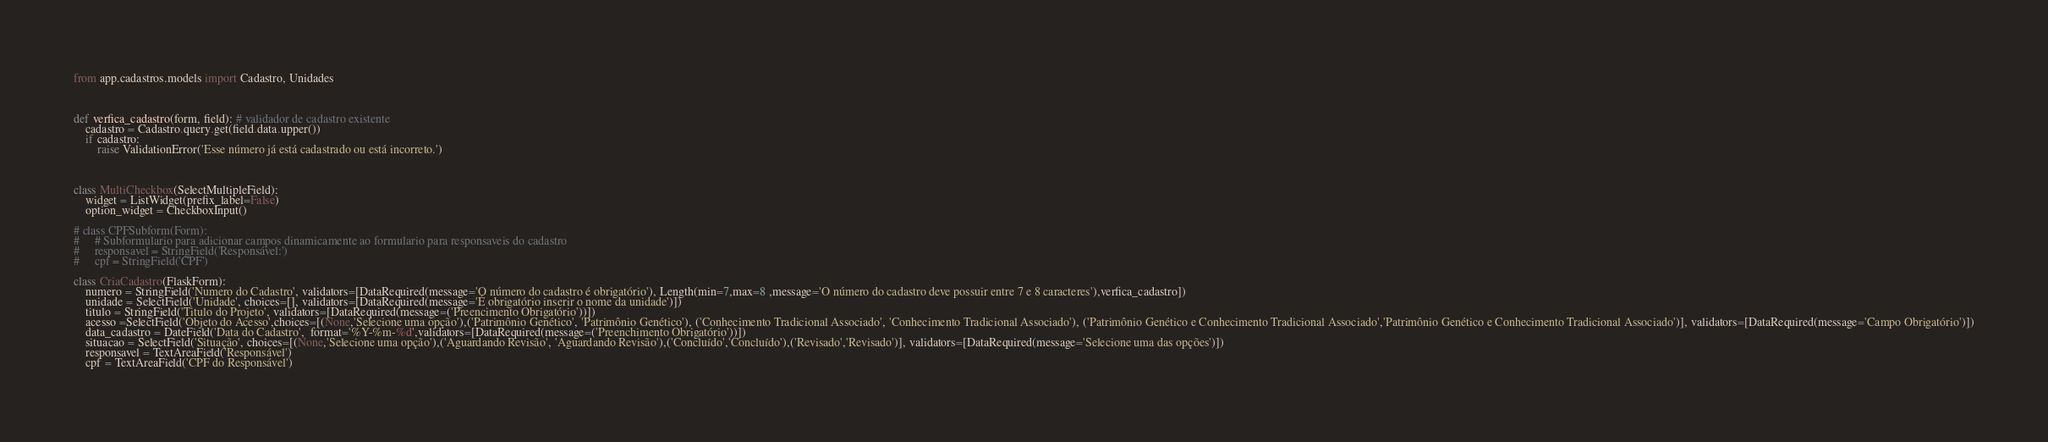Convert code to text. <code><loc_0><loc_0><loc_500><loc_500><_Python_>from app.cadastros.models import Cadastro, Unidades



def verfica_cadastro(form, field): # validador de cadastro existente
    cadastro = Cadastro.query.get(field.data.upper())
    if cadastro:
        raise ValidationError('Esse número já está cadastrado ou está incorreto.')



class MultiCheckbox(SelectMultipleField):
    widget = ListWidget(prefix_label=False)
    option_widget = CheckboxInput()

# class CPFSubform(Form):
#     # Subformulario para adicionar campos dinamicamente ao formulario para responsaveis do cadastro
#     responsavel = StringField('Responsável:')
#     cpf = StringField('CPF')

class CriaCadastro(FlaskForm):
    numero = StringField('Numero do Cadastro', validators=[DataRequired(message='O número do cadastro é obrigatório'), Length(min=7,max=8 ,message='O número do cadastro deve possuir entre 7 e 8 caracteres'),verfica_cadastro])
    unidade = SelectField('Unidade', choices=[], validators=[DataRequired(message='É obrigatório inserir o nome da unidade')])
    titulo = StringField('Titulo do Projeto', validators=[DataRequired(message=('Preencimento Obrigatório'))])
    acesso =SelectField('Objeto do Acesso',choices=[(None,'Selecione uma opção'),('Patrimônio Genético', 'Patrimônio Genético'), ('Conhecimento Tradicional Associado', 'Conhecimento Tradicional Associado'), ('Patrimônio Genético e Conhecimento Tradicional Associado','Patrimônio Genético e Conhecimento Tradicional Associado')], validators=[DataRequired(message='Campo Obrigatório')])
    data_cadastro = DateField('Data do Cadastro',  format='%Y-%m-%d',validators=[DataRequired(message=('Preenchimento Obrigatório'))])
    situacao = SelectField('Situação', choices=[(None,'Selecione uma opção'),('Aguardando Revisão', 'Aguardando Revisão'),('Concluído','Concluído'),('Revisado','Revisado')], validators=[DataRequired(message='Selecione uma das opções')])
    responsavel = TextAreaField('Responsável')
    cpf = TextAreaField('CPF do Responsável')</code> 